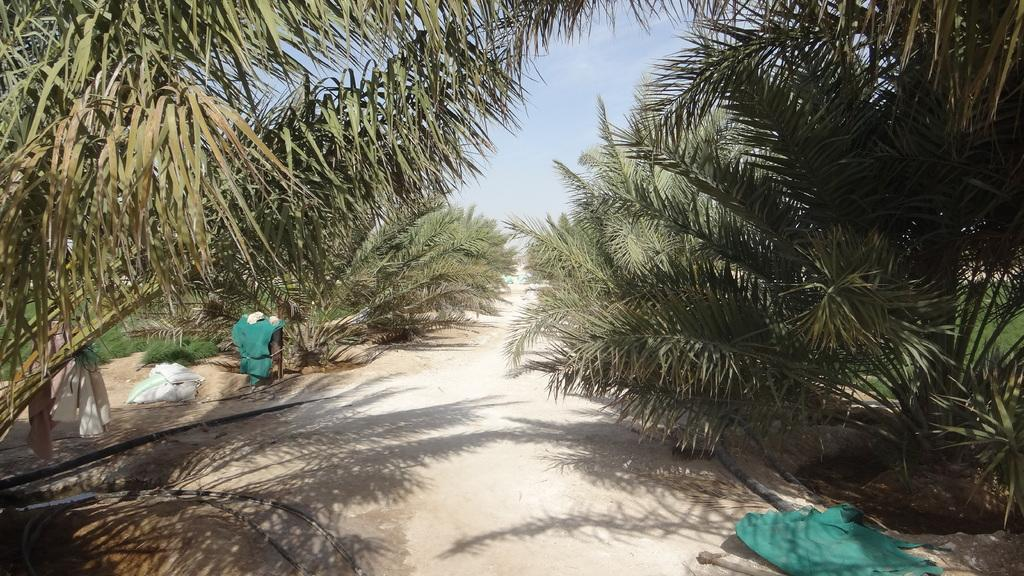What type of vegetation can be seen in the image? There are trees in the image. What items are visible in the image that might be used for carrying or storing things? There are bags in the image. What is visible in the background of the image? The sky is visible in the image. What color is the clothing that can be seen in the image? There are green color clothes in the image. Can you describe any other objects present in the image? There are other objects present in the image, but their specific details are not mentioned in the provided facts. What type of railway is visible in the image? There is no railway present in the image. Who is the writer in the image? There is no writer present in the image. 